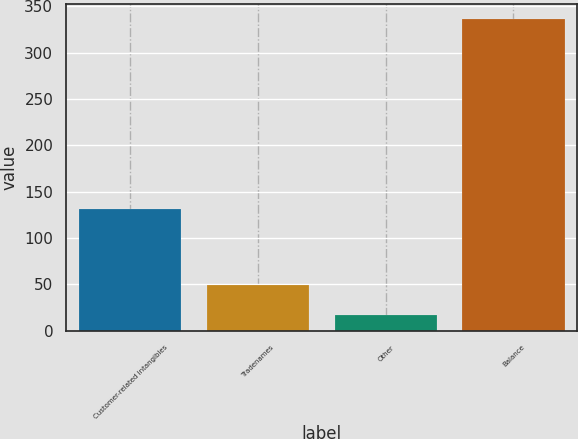Convert chart to OTSL. <chart><loc_0><loc_0><loc_500><loc_500><bar_chart><fcel>Customer-related intangibles<fcel>Tradenames<fcel>Other<fcel>Balance<nl><fcel>131<fcel>48.9<fcel>17<fcel>336<nl></chart> 